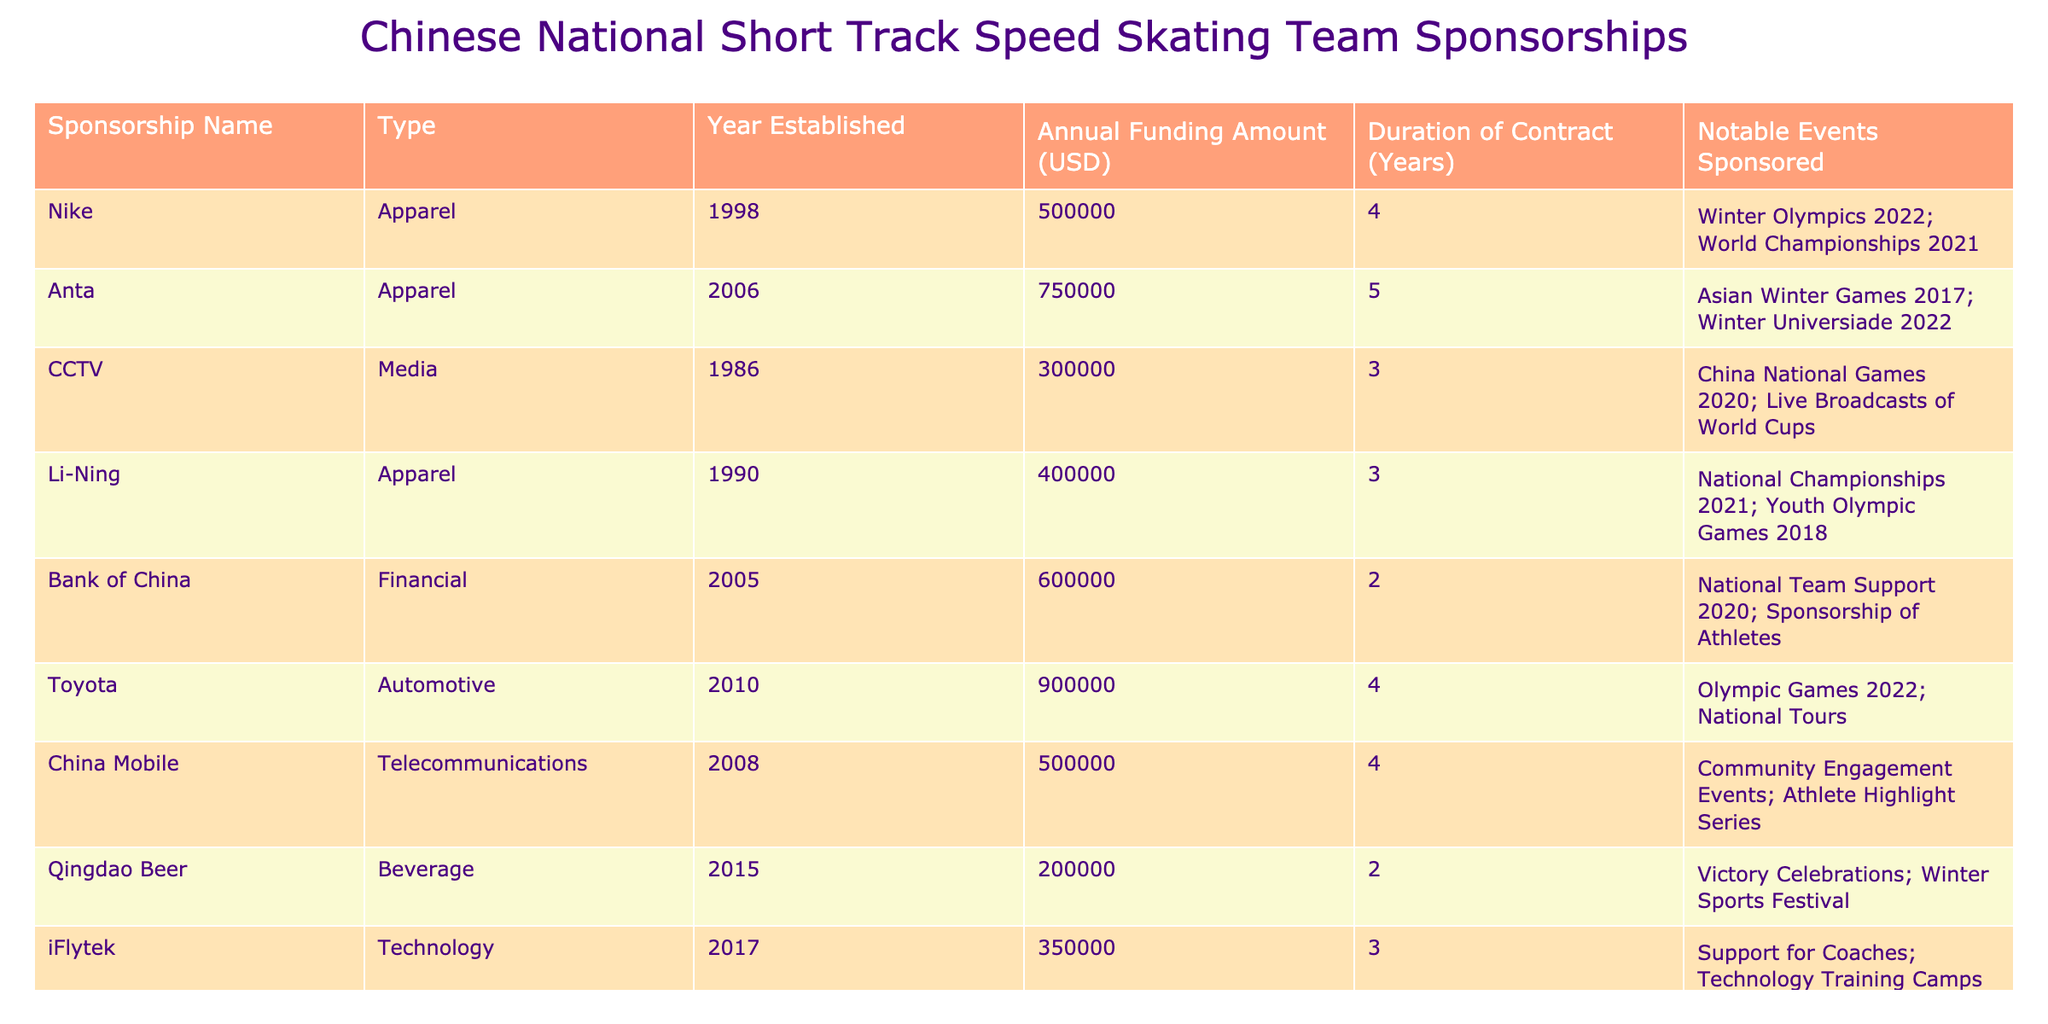What is the annual funding amount provided by Anta? From the table, the row corresponding to Anta shows that the annual funding amount listed under that sponsorship name is 750,000 USD.
Answer: 750,000 USD Which sponsorship has the longest duration of contract? Looking at the 'Duration of Contract' column, Anta and Ping An Insurance both have a duration of 5 years, which is the maximum.
Answer: Anta and Ping An Insurance How much total annual funding do the financial sponsors provide? The financial sponsors listed are Bank of China and Ping An Insurance. Their annual funding amounts are 600,000 and 800,000 USD respectively. Summing these gives 600,000 + 800,000 = 1,400,000 USD.
Answer: 1,400,000 USD Has Nike sponsored any events besides the Winter Olympics? In the 'Notable Events Sponsored' column for Nike, it mentions both the Winter Olympics 2022 and World Championships 2021. Therefore, it has sponsored other events.
Answer: Yes What is the average annual funding amount for the apparel sponsors? The apparel sponsors are Nike, Anta, Li-Ning, and iFlytek. Their funding amounts are 500,000, 750,000, 400,000, and 350,000 respectively. The sum is 500,000 + 750,000 + 400,000 + 350,000 = 2,000,000. There are 4 sponsors, so the average is 2,000,000 / 4 = 500,000 USD.
Answer: 500,000 USD Which sponsorship has the lowest annual funding amount? By checking the 'Annual Funding Amount' column, Qingdao Beer has the lowest amount listed, which is 200,000 USD.
Answer: 200,000 USD If you combine the annual funding amount of all media sponsors, what is the total? The only media sponsor listed is CCTV with an annual funding of 300,000 USD. Thus, the total annual funding from media sponsors is just this amount: 300,000 USD.
Answer: 300,000 USD Are there any sponsors established after 2015 that provide funding greater than 300,000 USD? After checking the 'Year Established' and 'Annual Funding Amount' columns, only iFlytek, established in 2017 with a funding amount of 350,000 USD fits this criterion.
Answer: Yes What is the total funding provided by all sponsorships listed for events in the year 2022? The relevant sponsors for events in 2022 are Anta (750,000), Toyota (900,000), and CCTV (300,000). Adding those amounts gives 750,000 + 900,000 + 300,000 = 1,950,000 USD.
Answer: 1,950,000 USD Is there a correlation between the year established and the annual funding amount for the sponsors? A detailed analysis of the years and corresponding funding requires examining all rows. However, it appears that older sponsors like Nike (1998) and newer sponsors like iFlytek (2017) can have varying amounts, indicating no simple correlation can be observed directly.
Answer: No clear correlation 